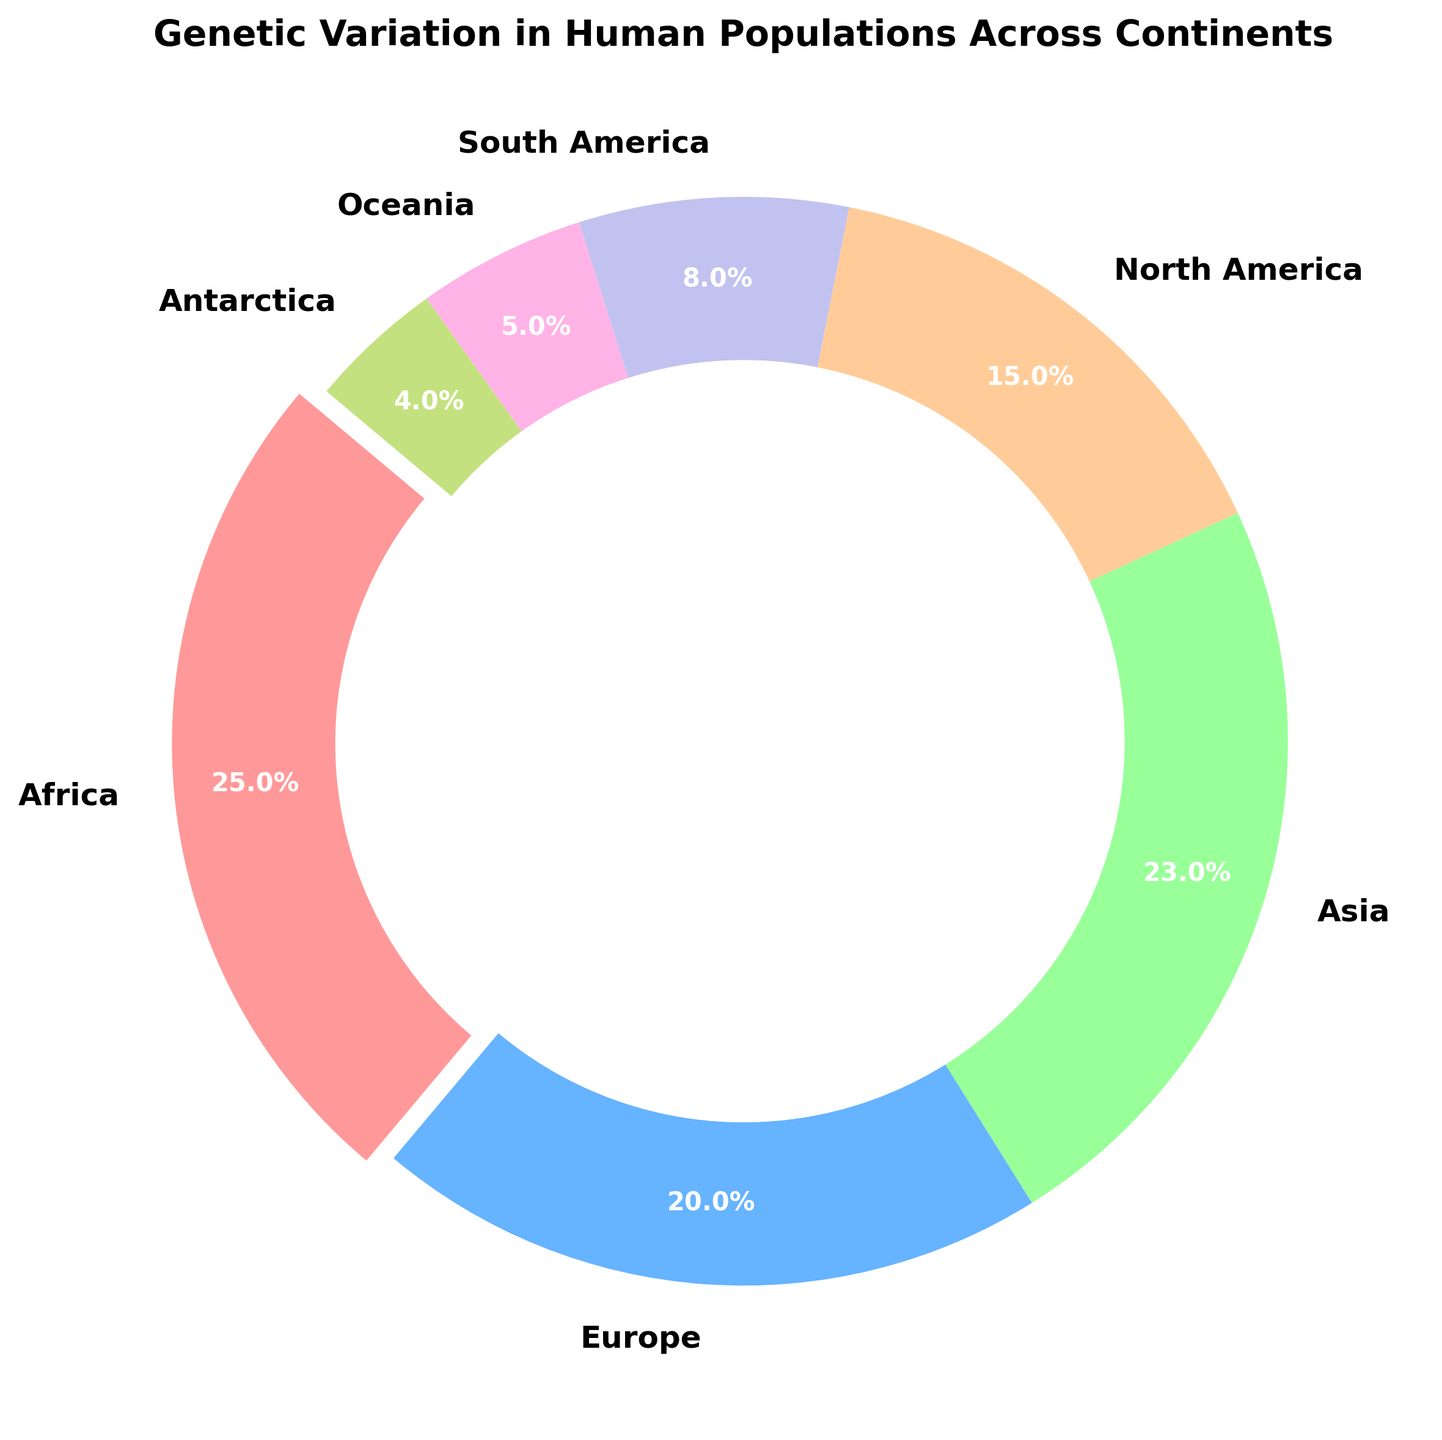Which continent has the highest genetic variation percentage? The segment representing Africa has the largest portion of the ring chart. The legend indicates that Africa has 25% genetic variation, which is the highest among all the continents represented.
Answer: Africa Which two continents together account for over 40% of the genetic variation? Summing the genetic variation percentages for Asia (23%) and Europe (20%) equals 43%, which is more than 40%.
Answer: Asia and Europe What is the difference in genetic variation percentage between South America and Oceania? According to the legend, South America has 8% and Oceania has 5%. The difference between them is 8% - 5% = 3%.
Answer: 3% How much more genetic variation does Africa have compared to North America? Africa has 25% genetic variation, while North America has 15%. The difference is 25% - 15% = 10%.
Answer: 10% Which continents have less than 10% genetic variation? The legend shows that South America (8%), Oceania (5%), and Antarctica (4%) each have less than 10% genetic variation.
Answer: South America, Oceania, and Antarctica What is the total genetic variation percentage represented by all continents? Adding up the genetic variation percentages for Africa (25%), Europe (20%), Asia (23%), North America (15%), South America (8%), Oceania (5%), and Antarctica (4%) gives 100%.
Answer: 100% Which segment is slightly exploded in the ring chart? The segment representing Africa is slightly exploded to emphasize it since it has the highest genetic variation percentage of 25%.
Answer: Africa How much genetic variation do continents other than Africa have combined? Subtracting Africa's genetic variation percentage (25%) from the total (100%) leaves 75%.
Answer: 75% What percentage of genetic variation does North America and Oceania together contribute? Summing North America's (15%) and Oceania's (5%) genetic variation percentages gives 15% + 5% = 20%.
Answer: 20% Which continents have similar genetic variation percentages? Europe (20%) and Asia (23%) have close genetic variation percentages, with only a 3% difference between them.
Answer: Europe and Asia 